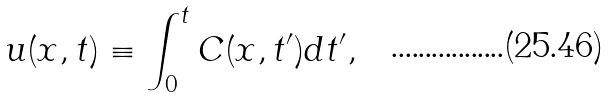<formula> <loc_0><loc_0><loc_500><loc_500>u ( x , t ) \equiv \int _ { 0 } ^ { t } C ( x , t ^ { \prime } ) d t ^ { \prime } ,</formula> 